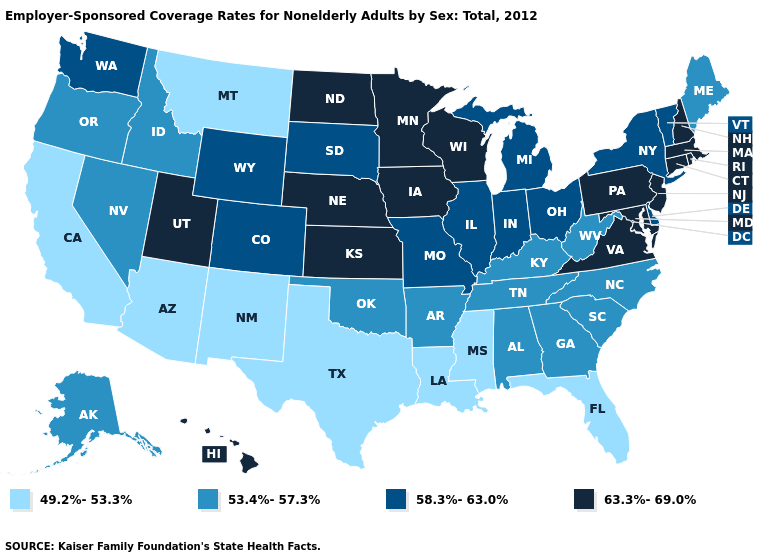Name the states that have a value in the range 63.3%-69.0%?
Keep it brief. Connecticut, Hawaii, Iowa, Kansas, Maryland, Massachusetts, Minnesota, Nebraska, New Hampshire, New Jersey, North Dakota, Pennsylvania, Rhode Island, Utah, Virginia, Wisconsin. Does the map have missing data?
Be succinct. No. What is the value of Hawaii?
Keep it brief. 63.3%-69.0%. Name the states that have a value in the range 63.3%-69.0%?
Answer briefly. Connecticut, Hawaii, Iowa, Kansas, Maryland, Massachusetts, Minnesota, Nebraska, New Hampshire, New Jersey, North Dakota, Pennsylvania, Rhode Island, Utah, Virginia, Wisconsin. Does the first symbol in the legend represent the smallest category?
Keep it brief. Yes. Is the legend a continuous bar?
Write a very short answer. No. What is the highest value in the USA?
Concise answer only. 63.3%-69.0%. Among the states that border Louisiana , which have the highest value?
Write a very short answer. Arkansas. Name the states that have a value in the range 53.4%-57.3%?
Be succinct. Alabama, Alaska, Arkansas, Georgia, Idaho, Kentucky, Maine, Nevada, North Carolina, Oklahoma, Oregon, South Carolina, Tennessee, West Virginia. Is the legend a continuous bar?
Concise answer only. No. Among the states that border Colorado , does Wyoming have the lowest value?
Give a very brief answer. No. What is the value of Alabama?
Quick response, please. 53.4%-57.3%. Among the states that border Pennsylvania , which have the lowest value?
Short answer required. West Virginia. 